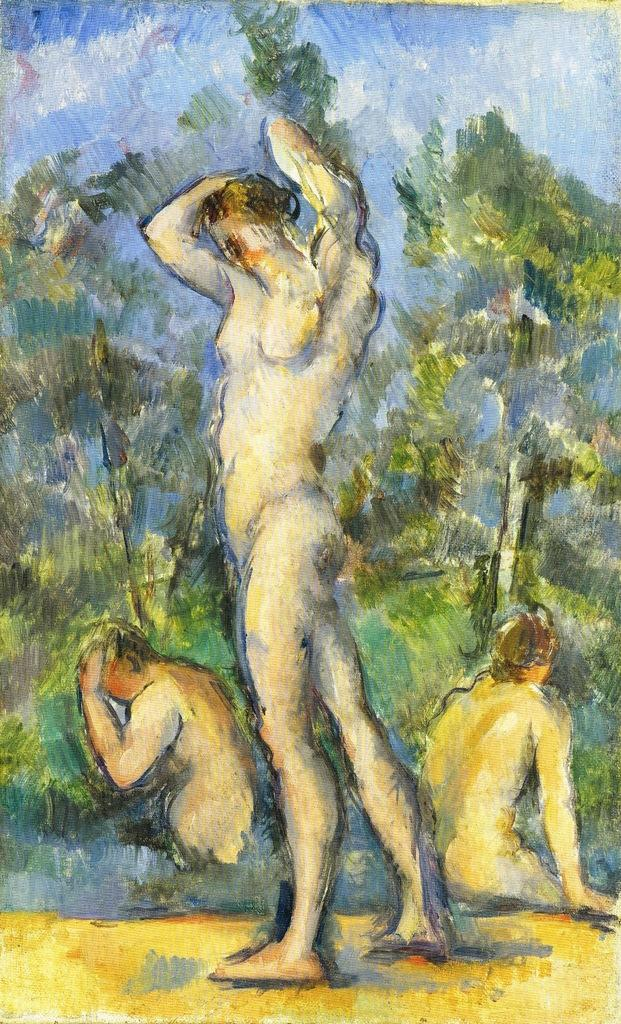What is depicted in the painting in the image? There is a painting of a man in the image. What can be seen in the background of the painting? There are trees in the background of the image. How many other persons are present in the painting? There are two persons beside the man in the painting. What type of sail can be seen on the man's clothing in the image? There is no sail present on the man's clothing in the image. How does the fire affect the painting in the image? There is no fire present in the image; it is a painting of a man with trees in the background and two other persons beside him. 